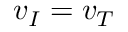<formula> <loc_0><loc_0><loc_500><loc_500>v _ { I } = v _ { T }</formula> 